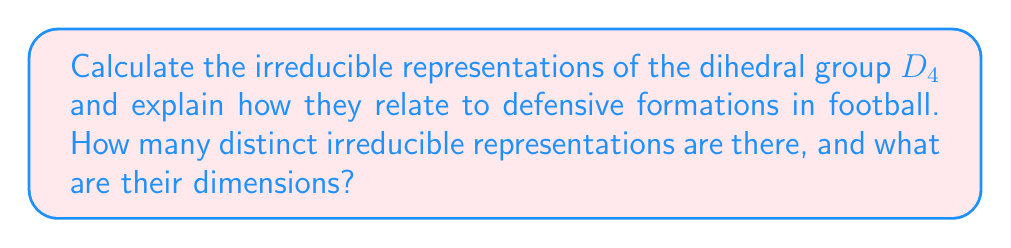Can you solve this math problem? Let's approach this step-by-step:

1) First, recall that the dihedral group $D_4$ has 8 elements: 4 rotations and 4 reflections. We can think of these as different defensive alignments on the field.

2) To find the irreducible representations, we use the formula:
   $$ \sum_{i=1}^{k} n_i^2 = |G| = 8 $$
   where $n_i$ are the dimensions of the irreducible representations and $k$ is the number of conjugacy classes.

3) $D_4$ has 5 conjugacy classes:
   - $\{e\}$ (identity, base defense)
   - $\{r^2\}$ (180° rotation, flipped defense)
   - $\{r, r^3\}$ (90° and 270° rotations, slightly shifted defenses)
   - $\{s, sr^2\}$ (reflections across x and y axes, mirrored defenses)
   - $\{sr, sr^3\}$ (reflections across diagonals, diagonally mirrored defenses)

4) We know there must be 5 irreducible representations (one for each conjugacy class). Let's call their dimensions $n_1, n_2, n_3, n_4, n_5$.

5) We always have the trivial representation (dimension 1) and, for non-abelian groups like $D_4$, we always have a sign representation (also dimension 1).

6) So we have: $1^2 + 1^2 + n_3^2 + n_4^2 + n_5^2 = 8$

7) The only integer solution for this equation is: $1^2 + 1^2 + 1^2 + 1^2 + 2^2 = 8$

8) Therefore, $D_4$ has four 1-dimensional irreducible representations and one 2-dimensional irreducible representation.

9) In terms of football strategy, we can interpret these as follows:
   - The four 1-dimensional representations correspond to simple defensive shifts or mirrors.
   - The 2-dimensional representation corresponds to more complex rotations or combinations of defensive movements.
Answer: 5 irreducible representations: four 1-dimensional and one 2-dimensional 